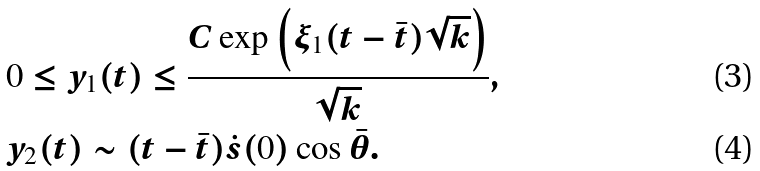Convert formula to latex. <formula><loc_0><loc_0><loc_500><loc_500>& 0 \leq y _ { 1 } ( t ) \leq \frac { C \exp \left ( \xi _ { 1 } ( t - \bar { t } ) \sqrt { k } \right ) } { \sqrt { k } } , \\ & y _ { 2 } ( t ) \sim ( t - \bar { t } ) \dot { s } ( 0 ) \cos \bar { \theta } .</formula> 